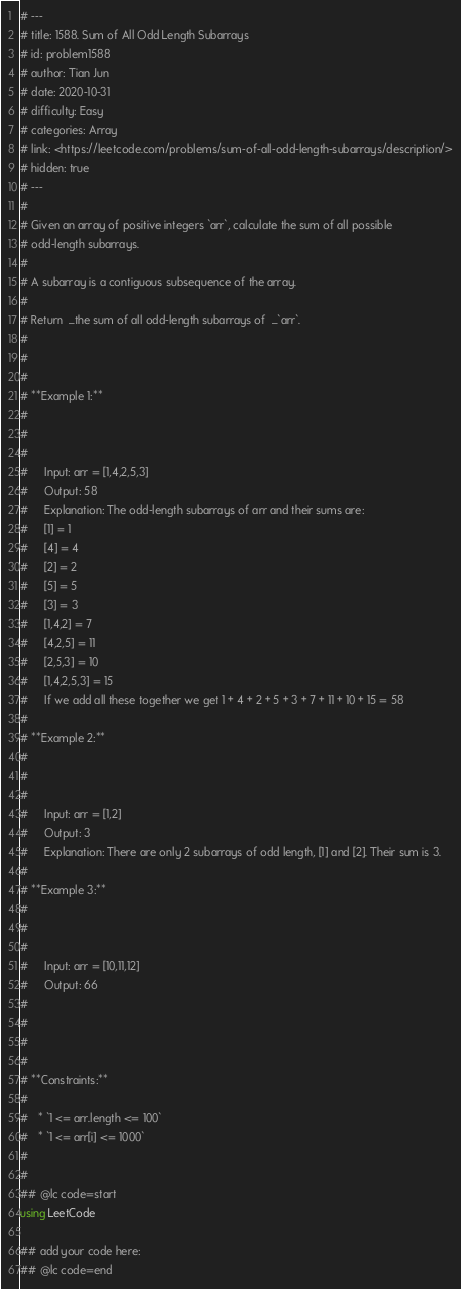Convert code to text. <code><loc_0><loc_0><loc_500><loc_500><_Julia_># ---
# title: 1588. Sum of All Odd Length Subarrays
# id: problem1588
# author: Tian Jun
# date: 2020-10-31
# difficulty: Easy
# categories: Array
# link: <https://leetcode.com/problems/sum-of-all-odd-length-subarrays/description/>
# hidden: true
# ---
# 
# Given an array of positive integers `arr`, calculate the sum of all possible
# odd-length subarrays.
# 
# A subarray is a contiguous subsequence of the array.
# 
# Return  _the sum of all odd-length subarrays of  _`arr`.
# 
# 
# 
# **Example 1:**
# 
#     
#     
#     Input: arr = [1,4,2,5,3]
#     Output: 58
#     Explanation: The odd-length subarrays of arr and their sums are:
#     [1] = 1
#     [4] = 4
#     [2] = 2
#     [5] = 5
#     [3] = 3
#     [1,4,2] = 7
#     [4,2,5] = 11
#     [2,5,3] = 10
#     [1,4,2,5,3] = 15
#     If we add all these together we get 1 + 4 + 2 + 5 + 3 + 7 + 11 + 10 + 15 = 58
# 
# **Example 2:**
# 
#     
#     
#     Input: arr = [1,2]
#     Output: 3
#     Explanation: There are only 2 subarrays of odd length, [1] and [2]. Their sum is 3.
# 
# **Example 3:**
# 
#     
#     
#     Input: arr = [10,11,12]
#     Output: 66
#     
# 
# 
# 
# **Constraints:**
# 
#   * `1 <= arr.length <= 100`
#   * `1 <= arr[i] <= 1000`
# 
# 
## @lc code=start
using LeetCode

## add your code here:
## @lc code=end
</code> 